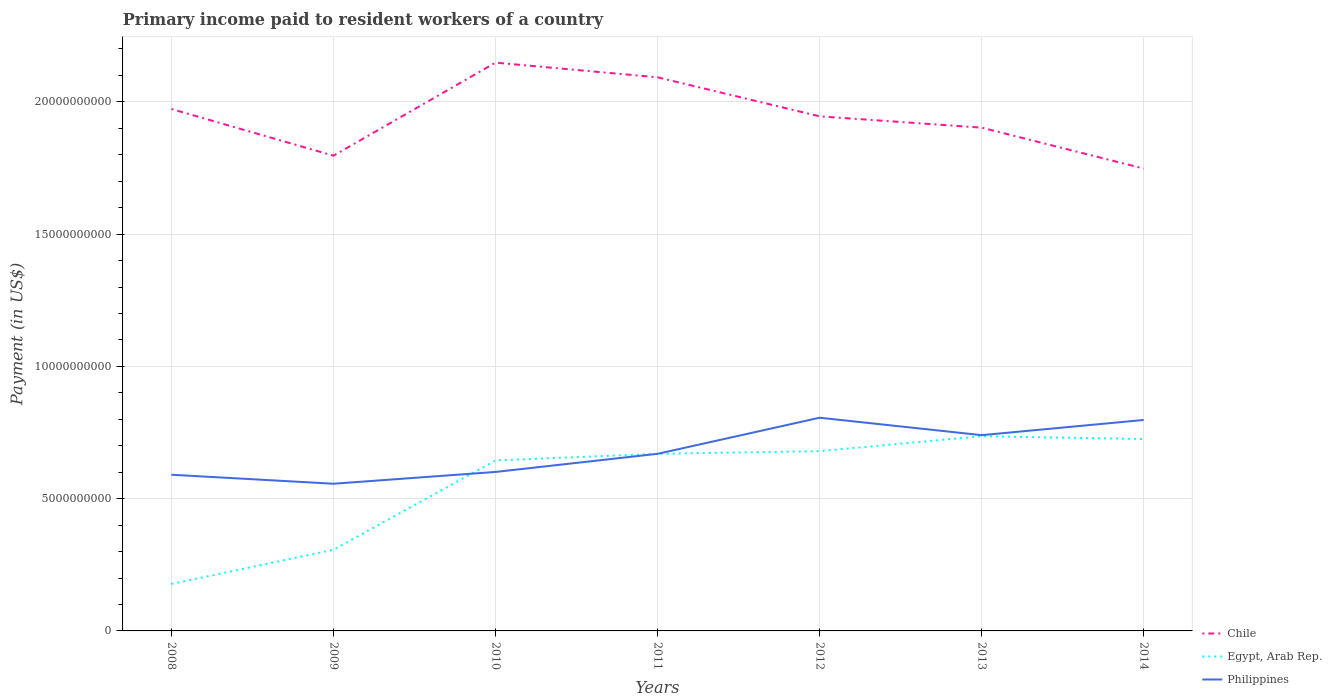Does the line corresponding to Egypt, Arab Rep. intersect with the line corresponding to Chile?
Provide a short and direct response. No. Is the number of lines equal to the number of legend labels?
Ensure brevity in your answer.  Yes. Across all years, what is the maximum amount paid to workers in Egypt, Arab Rep.?
Keep it short and to the point. 1.78e+09. In which year was the amount paid to workers in Philippines maximum?
Keep it short and to the point. 2009. What is the total amount paid to workers in Chile in the graph?
Offer a very short reply. -2.96e+09. What is the difference between the highest and the second highest amount paid to workers in Chile?
Make the answer very short. 4.00e+09. What is the difference between the highest and the lowest amount paid to workers in Chile?
Provide a short and direct response. 4. What is the difference between two consecutive major ticks on the Y-axis?
Offer a very short reply. 5.00e+09. Are the values on the major ticks of Y-axis written in scientific E-notation?
Offer a very short reply. No. Does the graph contain any zero values?
Keep it short and to the point. No. Does the graph contain grids?
Make the answer very short. Yes. Where does the legend appear in the graph?
Your answer should be very brief. Bottom right. How many legend labels are there?
Keep it short and to the point. 3. How are the legend labels stacked?
Your answer should be compact. Vertical. What is the title of the graph?
Keep it short and to the point. Primary income paid to resident workers of a country. What is the label or title of the Y-axis?
Your answer should be compact. Payment (in US$). What is the Payment (in US$) of Chile in 2008?
Give a very brief answer. 1.97e+1. What is the Payment (in US$) in Egypt, Arab Rep. in 2008?
Provide a succinct answer. 1.78e+09. What is the Payment (in US$) of Philippines in 2008?
Your answer should be compact. 5.90e+09. What is the Payment (in US$) of Chile in 2009?
Your answer should be very brief. 1.80e+1. What is the Payment (in US$) of Egypt, Arab Rep. in 2009?
Offer a very short reply. 3.07e+09. What is the Payment (in US$) of Philippines in 2009?
Your answer should be compact. 5.56e+09. What is the Payment (in US$) in Chile in 2010?
Make the answer very short. 2.15e+1. What is the Payment (in US$) in Egypt, Arab Rep. in 2010?
Provide a short and direct response. 6.45e+09. What is the Payment (in US$) of Philippines in 2010?
Keep it short and to the point. 6.01e+09. What is the Payment (in US$) of Chile in 2011?
Your response must be concise. 2.09e+1. What is the Payment (in US$) in Egypt, Arab Rep. in 2011?
Offer a very short reply. 6.69e+09. What is the Payment (in US$) of Philippines in 2011?
Make the answer very short. 6.70e+09. What is the Payment (in US$) of Chile in 2012?
Your response must be concise. 1.95e+1. What is the Payment (in US$) in Egypt, Arab Rep. in 2012?
Your response must be concise. 6.80e+09. What is the Payment (in US$) of Philippines in 2012?
Your response must be concise. 8.06e+09. What is the Payment (in US$) of Chile in 2013?
Ensure brevity in your answer.  1.90e+1. What is the Payment (in US$) of Egypt, Arab Rep. in 2013?
Your answer should be very brief. 7.36e+09. What is the Payment (in US$) in Philippines in 2013?
Your answer should be very brief. 7.40e+09. What is the Payment (in US$) of Chile in 2014?
Your response must be concise. 1.75e+1. What is the Payment (in US$) in Egypt, Arab Rep. in 2014?
Your response must be concise. 7.25e+09. What is the Payment (in US$) in Philippines in 2014?
Your answer should be compact. 7.97e+09. Across all years, what is the maximum Payment (in US$) in Chile?
Offer a very short reply. 2.15e+1. Across all years, what is the maximum Payment (in US$) in Egypt, Arab Rep.?
Your answer should be very brief. 7.36e+09. Across all years, what is the maximum Payment (in US$) in Philippines?
Your response must be concise. 8.06e+09. Across all years, what is the minimum Payment (in US$) of Chile?
Offer a very short reply. 1.75e+1. Across all years, what is the minimum Payment (in US$) of Egypt, Arab Rep.?
Your answer should be very brief. 1.78e+09. Across all years, what is the minimum Payment (in US$) in Philippines?
Your response must be concise. 5.56e+09. What is the total Payment (in US$) in Chile in the graph?
Ensure brevity in your answer.  1.36e+11. What is the total Payment (in US$) in Egypt, Arab Rep. in the graph?
Your answer should be very brief. 3.94e+1. What is the total Payment (in US$) in Philippines in the graph?
Offer a terse response. 4.76e+1. What is the difference between the Payment (in US$) in Chile in 2008 and that in 2009?
Give a very brief answer. 1.76e+09. What is the difference between the Payment (in US$) of Egypt, Arab Rep. in 2008 and that in 2009?
Offer a terse response. -1.29e+09. What is the difference between the Payment (in US$) in Philippines in 2008 and that in 2009?
Give a very brief answer. 3.40e+08. What is the difference between the Payment (in US$) of Chile in 2008 and that in 2010?
Your response must be concise. -1.75e+09. What is the difference between the Payment (in US$) in Egypt, Arab Rep. in 2008 and that in 2010?
Ensure brevity in your answer.  -4.67e+09. What is the difference between the Payment (in US$) of Philippines in 2008 and that in 2010?
Offer a terse response. -1.06e+08. What is the difference between the Payment (in US$) of Chile in 2008 and that in 2011?
Your answer should be compact. -1.20e+09. What is the difference between the Payment (in US$) in Egypt, Arab Rep. in 2008 and that in 2011?
Keep it short and to the point. -4.92e+09. What is the difference between the Payment (in US$) of Philippines in 2008 and that in 2011?
Offer a very short reply. -7.91e+08. What is the difference between the Payment (in US$) of Chile in 2008 and that in 2012?
Provide a succinct answer. 2.77e+08. What is the difference between the Payment (in US$) of Egypt, Arab Rep. in 2008 and that in 2012?
Provide a succinct answer. -5.02e+09. What is the difference between the Payment (in US$) of Philippines in 2008 and that in 2012?
Your answer should be very brief. -2.16e+09. What is the difference between the Payment (in US$) of Chile in 2008 and that in 2013?
Offer a very short reply. 7.05e+08. What is the difference between the Payment (in US$) in Egypt, Arab Rep. in 2008 and that in 2013?
Offer a terse response. -5.58e+09. What is the difference between the Payment (in US$) in Philippines in 2008 and that in 2013?
Ensure brevity in your answer.  -1.50e+09. What is the difference between the Payment (in US$) of Chile in 2008 and that in 2014?
Keep it short and to the point. 2.25e+09. What is the difference between the Payment (in US$) of Egypt, Arab Rep. in 2008 and that in 2014?
Your response must be concise. -5.48e+09. What is the difference between the Payment (in US$) in Philippines in 2008 and that in 2014?
Ensure brevity in your answer.  -2.07e+09. What is the difference between the Payment (in US$) in Chile in 2009 and that in 2010?
Provide a short and direct response. -3.52e+09. What is the difference between the Payment (in US$) in Egypt, Arab Rep. in 2009 and that in 2010?
Keep it short and to the point. -3.38e+09. What is the difference between the Payment (in US$) in Philippines in 2009 and that in 2010?
Your answer should be very brief. -4.46e+08. What is the difference between the Payment (in US$) of Chile in 2009 and that in 2011?
Give a very brief answer. -2.96e+09. What is the difference between the Payment (in US$) in Egypt, Arab Rep. in 2009 and that in 2011?
Make the answer very short. -3.63e+09. What is the difference between the Payment (in US$) in Philippines in 2009 and that in 2011?
Provide a short and direct response. -1.13e+09. What is the difference between the Payment (in US$) in Chile in 2009 and that in 2012?
Provide a short and direct response. -1.49e+09. What is the difference between the Payment (in US$) in Egypt, Arab Rep. in 2009 and that in 2012?
Offer a very short reply. -3.73e+09. What is the difference between the Payment (in US$) of Philippines in 2009 and that in 2012?
Offer a very short reply. -2.50e+09. What is the difference between the Payment (in US$) of Chile in 2009 and that in 2013?
Make the answer very short. -1.06e+09. What is the difference between the Payment (in US$) of Egypt, Arab Rep. in 2009 and that in 2013?
Give a very brief answer. -4.29e+09. What is the difference between the Payment (in US$) in Philippines in 2009 and that in 2013?
Keep it short and to the point. -1.84e+09. What is the difference between the Payment (in US$) of Chile in 2009 and that in 2014?
Give a very brief answer. 4.86e+08. What is the difference between the Payment (in US$) of Egypt, Arab Rep. in 2009 and that in 2014?
Your answer should be very brief. -4.19e+09. What is the difference between the Payment (in US$) of Philippines in 2009 and that in 2014?
Offer a very short reply. -2.41e+09. What is the difference between the Payment (in US$) in Chile in 2010 and that in 2011?
Give a very brief answer. 5.54e+08. What is the difference between the Payment (in US$) in Egypt, Arab Rep. in 2010 and that in 2011?
Your response must be concise. -2.49e+08. What is the difference between the Payment (in US$) in Philippines in 2010 and that in 2011?
Your response must be concise. -6.85e+08. What is the difference between the Payment (in US$) of Chile in 2010 and that in 2012?
Offer a very short reply. 2.03e+09. What is the difference between the Payment (in US$) in Egypt, Arab Rep. in 2010 and that in 2012?
Offer a very short reply. -3.51e+08. What is the difference between the Payment (in US$) in Philippines in 2010 and that in 2012?
Keep it short and to the point. -2.05e+09. What is the difference between the Payment (in US$) in Chile in 2010 and that in 2013?
Your answer should be very brief. 2.46e+09. What is the difference between the Payment (in US$) in Egypt, Arab Rep. in 2010 and that in 2013?
Provide a short and direct response. -9.14e+08. What is the difference between the Payment (in US$) in Philippines in 2010 and that in 2013?
Ensure brevity in your answer.  -1.39e+09. What is the difference between the Payment (in US$) of Chile in 2010 and that in 2014?
Give a very brief answer. 4.00e+09. What is the difference between the Payment (in US$) of Egypt, Arab Rep. in 2010 and that in 2014?
Your answer should be very brief. -8.09e+08. What is the difference between the Payment (in US$) in Philippines in 2010 and that in 2014?
Make the answer very short. -1.96e+09. What is the difference between the Payment (in US$) of Chile in 2011 and that in 2012?
Provide a short and direct response. 1.48e+09. What is the difference between the Payment (in US$) of Egypt, Arab Rep. in 2011 and that in 2012?
Your answer should be very brief. -1.01e+08. What is the difference between the Payment (in US$) of Philippines in 2011 and that in 2012?
Your response must be concise. -1.36e+09. What is the difference between the Payment (in US$) in Chile in 2011 and that in 2013?
Keep it short and to the point. 1.90e+09. What is the difference between the Payment (in US$) in Egypt, Arab Rep. in 2011 and that in 2013?
Provide a succinct answer. -6.65e+08. What is the difference between the Payment (in US$) in Philippines in 2011 and that in 2013?
Provide a short and direct response. -7.06e+08. What is the difference between the Payment (in US$) of Chile in 2011 and that in 2014?
Provide a succinct answer. 3.45e+09. What is the difference between the Payment (in US$) of Egypt, Arab Rep. in 2011 and that in 2014?
Keep it short and to the point. -5.60e+08. What is the difference between the Payment (in US$) of Philippines in 2011 and that in 2014?
Your response must be concise. -1.28e+09. What is the difference between the Payment (in US$) of Chile in 2012 and that in 2013?
Your response must be concise. 4.28e+08. What is the difference between the Payment (in US$) of Egypt, Arab Rep. in 2012 and that in 2013?
Offer a very short reply. -5.64e+08. What is the difference between the Payment (in US$) in Philippines in 2012 and that in 2013?
Offer a terse response. 6.59e+08. What is the difference between the Payment (in US$) of Chile in 2012 and that in 2014?
Offer a very short reply. 1.97e+09. What is the difference between the Payment (in US$) of Egypt, Arab Rep. in 2012 and that in 2014?
Give a very brief answer. -4.58e+08. What is the difference between the Payment (in US$) in Philippines in 2012 and that in 2014?
Offer a very short reply. 8.53e+07. What is the difference between the Payment (in US$) of Chile in 2013 and that in 2014?
Provide a succinct answer. 1.55e+09. What is the difference between the Payment (in US$) of Egypt, Arab Rep. in 2013 and that in 2014?
Ensure brevity in your answer.  1.06e+08. What is the difference between the Payment (in US$) in Philippines in 2013 and that in 2014?
Give a very brief answer. -5.74e+08. What is the difference between the Payment (in US$) in Chile in 2008 and the Payment (in US$) in Egypt, Arab Rep. in 2009?
Give a very brief answer. 1.67e+1. What is the difference between the Payment (in US$) in Chile in 2008 and the Payment (in US$) in Philippines in 2009?
Provide a short and direct response. 1.42e+1. What is the difference between the Payment (in US$) of Egypt, Arab Rep. in 2008 and the Payment (in US$) of Philippines in 2009?
Your response must be concise. -3.79e+09. What is the difference between the Payment (in US$) of Chile in 2008 and the Payment (in US$) of Egypt, Arab Rep. in 2010?
Provide a succinct answer. 1.33e+1. What is the difference between the Payment (in US$) of Chile in 2008 and the Payment (in US$) of Philippines in 2010?
Give a very brief answer. 1.37e+1. What is the difference between the Payment (in US$) of Egypt, Arab Rep. in 2008 and the Payment (in US$) of Philippines in 2010?
Provide a short and direct response. -4.23e+09. What is the difference between the Payment (in US$) in Chile in 2008 and the Payment (in US$) in Egypt, Arab Rep. in 2011?
Make the answer very short. 1.30e+1. What is the difference between the Payment (in US$) in Chile in 2008 and the Payment (in US$) in Philippines in 2011?
Your response must be concise. 1.30e+1. What is the difference between the Payment (in US$) in Egypt, Arab Rep. in 2008 and the Payment (in US$) in Philippines in 2011?
Give a very brief answer. -4.92e+09. What is the difference between the Payment (in US$) in Chile in 2008 and the Payment (in US$) in Egypt, Arab Rep. in 2012?
Offer a terse response. 1.29e+1. What is the difference between the Payment (in US$) in Chile in 2008 and the Payment (in US$) in Philippines in 2012?
Your answer should be compact. 1.17e+1. What is the difference between the Payment (in US$) in Egypt, Arab Rep. in 2008 and the Payment (in US$) in Philippines in 2012?
Offer a very short reply. -6.28e+09. What is the difference between the Payment (in US$) of Chile in 2008 and the Payment (in US$) of Egypt, Arab Rep. in 2013?
Give a very brief answer. 1.24e+1. What is the difference between the Payment (in US$) of Chile in 2008 and the Payment (in US$) of Philippines in 2013?
Provide a short and direct response. 1.23e+1. What is the difference between the Payment (in US$) of Egypt, Arab Rep. in 2008 and the Payment (in US$) of Philippines in 2013?
Provide a succinct answer. -5.62e+09. What is the difference between the Payment (in US$) of Chile in 2008 and the Payment (in US$) of Egypt, Arab Rep. in 2014?
Your answer should be very brief. 1.25e+1. What is the difference between the Payment (in US$) in Chile in 2008 and the Payment (in US$) in Philippines in 2014?
Your answer should be very brief. 1.18e+1. What is the difference between the Payment (in US$) of Egypt, Arab Rep. in 2008 and the Payment (in US$) of Philippines in 2014?
Provide a short and direct response. -6.20e+09. What is the difference between the Payment (in US$) of Chile in 2009 and the Payment (in US$) of Egypt, Arab Rep. in 2010?
Keep it short and to the point. 1.15e+1. What is the difference between the Payment (in US$) of Chile in 2009 and the Payment (in US$) of Philippines in 2010?
Provide a short and direct response. 1.20e+1. What is the difference between the Payment (in US$) of Egypt, Arab Rep. in 2009 and the Payment (in US$) of Philippines in 2010?
Your answer should be compact. -2.94e+09. What is the difference between the Payment (in US$) of Chile in 2009 and the Payment (in US$) of Egypt, Arab Rep. in 2011?
Keep it short and to the point. 1.13e+1. What is the difference between the Payment (in US$) of Chile in 2009 and the Payment (in US$) of Philippines in 2011?
Ensure brevity in your answer.  1.13e+1. What is the difference between the Payment (in US$) in Egypt, Arab Rep. in 2009 and the Payment (in US$) in Philippines in 2011?
Your answer should be very brief. -3.63e+09. What is the difference between the Payment (in US$) of Chile in 2009 and the Payment (in US$) of Egypt, Arab Rep. in 2012?
Provide a short and direct response. 1.12e+1. What is the difference between the Payment (in US$) of Chile in 2009 and the Payment (in US$) of Philippines in 2012?
Make the answer very short. 9.91e+09. What is the difference between the Payment (in US$) in Egypt, Arab Rep. in 2009 and the Payment (in US$) in Philippines in 2012?
Offer a very short reply. -4.99e+09. What is the difference between the Payment (in US$) of Chile in 2009 and the Payment (in US$) of Egypt, Arab Rep. in 2013?
Provide a short and direct response. 1.06e+1. What is the difference between the Payment (in US$) of Chile in 2009 and the Payment (in US$) of Philippines in 2013?
Provide a short and direct response. 1.06e+1. What is the difference between the Payment (in US$) of Egypt, Arab Rep. in 2009 and the Payment (in US$) of Philippines in 2013?
Provide a short and direct response. -4.33e+09. What is the difference between the Payment (in US$) in Chile in 2009 and the Payment (in US$) in Egypt, Arab Rep. in 2014?
Provide a succinct answer. 1.07e+1. What is the difference between the Payment (in US$) of Chile in 2009 and the Payment (in US$) of Philippines in 2014?
Offer a terse response. 9.99e+09. What is the difference between the Payment (in US$) of Egypt, Arab Rep. in 2009 and the Payment (in US$) of Philippines in 2014?
Offer a very short reply. -4.91e+09. What is the difference between the Payment (in US$) in Chile in 2010 and the Payment (in US$) in Egypt, Arab Rep. in 2011?
Keep it short and to the point. 1.48e+1. What is the difference between the Payment (in US$) of Chile in 2010 and the Payment (in US$) of Philippines in 2011?
Make the answer very short. 1.48e+1. What is the difference between the Payment (in US$) in Egypt, Arab Rep. in 2010 and the Payment (in US$) in Philippines in 2011?
Provide a succinct answer. -2.50e+08. What is the difference between the Payment (in US$) in Chile in 2010 and the Payment (in US$) in Egypt, Arab Rep. in 2012?
Provide a succinct answer. 1.47e+1. What is the difference between the Payment (in US$) of Chile in 2010 and the Payment (in US$) of Philippines in 2012?
Ensure brevity in your answer.  1.34e+1. What is the difference between the Payment (in US$) in Egypt, Arab Rep. in 2010 and the Payment (in US$) in Philippines in 2012?
Give a very brief answer. -1.61e+09. What is the difference between the Payment (in US$) of Chile in 2010 and the Payment (in US$) of Egypt, Arab Rep. in 2013?
Provide a short and direct response. 1.41e+1. What is the difference between the Payment (in US$) of Chile in 2010 and the Payment (in US$) of Philippines in 2013?
Ensure brevity in your answer.  1.41e+1. What is the difference between the Payment (in US$) of Egypt, Arab Rep. in 2010 and the Payment (in US$) of Philippines in 2013?
Offer a very short reply. -9.55e+08. What is the difference between the Payment (in US$) of Chile in 2010 and the Payment (in US$) of Egypt, Arab Rep. in 2014?
Your answer should be very brief. 1.42e+1. What is the difference between the Payment (in US$) in Chile in 2010 and the Payment (in US$) in Philippines in 2014?
Keep it short and to the point. 1.35e+1. What is the difference between the Payment (in US$) of Egypt, Arab Rep. in 2010 and the Payment (in US$) of Philippines in 2014?
Offer a very short reply. -1.53e+09. What is the difference between the Payment (in US$) in Chile in 2011 and the Payment (in US$) in Egypt, Arab Rep. in 2012?
Your response must be concise. 1.41e+1. What is the difference between the Payment (in US$) in Chile in 2011 and the Payment (in US$) in Philippines in 2012?
Make the answer very short. 1.29e+1. What is the difference between the Payment (in US$) in Egypt, Arab Rep. in 2011 and the Payment (in US$) in Philippines in 2012?
Give a very brief answer. -1.37e+09. What is the difference between the Payment (in US$) in Chile in 2011 and the Payment (in US$) in Egypt, Arab Rep. in 2013?
Keep it short and to the point. 1.36e+1. What is the difference between the Payment (in US$) in Chile in 2011 and the Payment (in US$) in Philippines in 2013?
Make the answer very short. 1.35e+1. What is the difference between the Payment (in US$) in Egypt, Arab Rep. in 2011 and the Payment (in US$) in Philippines in 2013?
Provide a short and direct response. -7.06e+08. What is the difference between the Payment (in US$) of Chile in 2011 and the Payment (in US$) of Egypt, Arab Rep. in 2014?
Ensure brevity in your answer.  1.37e+1. What is the difference between the Payment (in US$) of Chile in 2011 and the Payment (in US$) of Philippines in 2014?
Offer a very short reply. 1.30e+1. What is the difference between the Payment (in US$) of Egypt, Arab Rep. in 2011 and the Payment (in US$) of Philippines in 2014?
Give a very brief answer. -1.28e+09. What is the difference between the Payment (in US$) of Chile in 2012 and the Payment (in US$) of Egypt, Arab Rep. in 2013?
Give a very brief answer. 1.21e+1. What is the difference between the Payment (in US$) in Chile in 2012 and the Payment (in US$) in Philippines in 2013?
Offer a terse response. 1.21e+1. What is the difference between the Payment (in US$) in Egypt, Arab Rep. in 2012 and the Payment (in US$) in Philippines in 2013?
Offer a very short reply. -6.05e+08. What is the difference between the Payment (in US$) in Chile in 2012 and the Payment (in US$) in Egypt, Arab Rep. in 2014?
Ensure brevity in your answer.  1.22e+1. What is the difference between the Payment (in US$) in Chile in 2012 and the Payment (in US$) in Philippines in 2014?
Offer a very short reply. 1.15e+1. What is the difference between the Payment (in US$) of Egypt, Arab Rep. in 2012 and the Payment (in US$) of Philippines in 2014?
Offer a very short reply. -1.18e+09. What is the difference between the Payment (in US$) in Chile in 2013 and the Payment (in US$) in Egypt, Arab Rep. in 2014?
Keep it short and to the point. 1.18e+1. What is the difference between the Payment (in US$) in Chile in 2013 and the Payment (in US$) in Philippines in 2014?
Give a very brief answer. 1.11e+1. What is the difference between the Payment (in US$) of Egypt, Arab Rep. in 2013 and the Payment (in US$) of Philippines in 2014?
Provide a short and direct response. -6.15e+08. What is the average Payment (in US$) in Chile per year?
Your response must be concise. 1.94e+1. What is the average Payment (in US$) in Egypt, Arab Rep. per year?
Offer a terse response. 5.63e+09. What is the average Payment (in US$) in Philippines per year?
Make the answer very short. 6.80e+09. In the year 2008, what is the difference between the Payment (in US$) in Chile and Payment (in US$) in Egypt, Arab Rep.?
Offer a terse response. 1.80e+1. In the year 2008, what is the difference between the Payment (in US$) of Chile and Payment (in US$) of Philippines?
Offer a very short reply. 1.38e+1. In the year 2008, what is the difference between the Payment (in US$) of Egypt, Arab Rep. and Payment (in US$) of Philippines?
Ensure brevity in your answer.  -4.13e+09. In the year 2009, what is the difference between the Payment (in US$) in Chile and Payment (in US$) in Egypt, Arab Rep.?
Your answer should be compact. 1.49e+1. In the year 2009, what is the difference between the Payment (in US$) of Chile and Payment (in US$) of Philippines?
Provide a short and direct response. 1.24e+1. In the year 2009, what is the difference between the Payment (in US$) of Egypt, Arab Rep. and Payment (in US$) of Philippines?
Offer a very short reply. -2.50e+09. In the year 2010, what is the difference between the Payment (in US$) in Chile and Payment (in US$) in Egypt, Arab Rep.?
Your answer should be compact. 1.50e+1. In the year 2010, what is the difference between the Payment (in US$) in Chile and Payment (in US$) in Philippines?
Offer a very short reply. 1.55e+1. In the year 2010, what is the difference between the Payment (in US$) in Egypt, Arab Rep. and Payment (in US$) in Philippines?
Keep it short and to the point. 4.35e+08. In the year 2011, what is the difference between the Payment (in US$) in Chile and Payment (in US$) in Egypt, Arab Rep.?
Your answer should be very brief. 1.42e+1. In the year 2011, what is the difference between the Payment (in US$) in Chile and Payment (in US$) in Philippines?
Make the answer very short. 1.42e+1. In the year 2011, what is the difference between the Payment (in US$) of Egypt, Arab Rep. and Payment (in US$) of Philippines?
Ensure brevity in your answer.  -5.25e+05. In the year 2012, what is the difference between the Payment (in US$) of Chile and Payment (in US$) of Egypt, Arab Rep.?
Keep it short and to the point. 1.27e+1. In the year 2012, what is the difference between the Payment (in US$) in Chile and Payment (in US$) in Philippines?
Make the answer very short. 1.14e+1. In the year 2012, what is the difference between the Payment (in US$) in Egypt, Arab Rep. and Payment (in US$) in Philippines?
Provide a short and direct response. -1.26e+09. In the year 2013, what is the difference between the Payment (in US$) of Chile and Payment (in US$) of Egypt, Arab Rep.?
Your answer should be compact. 1.17e+1. In the year 2013, what is the difference between the Payment (in US$) in Chile and Payment (in US$) in Philippines?
Offer a terse response. 1.16e+1. In the year 2013, what is the difference between the Payment (in US$) of Egypt, Arab Rep. and Payment (in US$) of Philippines?
Your answer should be very brief. -4.11e+07. In the year 2014, what is the difference between the Payment (in US$) of Chile and Payment (in US$) of Egypt, Arab Rep.?
Your answer should be compact. 1.02e+1. In the year 2014, what is the difference between the Payment (in US$) in Chile and Payment (in US$) in Philippines?
Make the answer very short. 9.51e+09. In the year 2014, what is the difference between the Payment (in US$) in Egypt, Arab Rep. and Payment (in US$) in Philippines?
Offer a very short reply. -7.20e+08. What is the ratio of the Payment (in US$) in Chile in 2008 to that in 2009?
Ensure brevity in your answer.  1.1. What is the ratio of the Payment (in US$) in Egypt, Arab Rep. in 2008 to that in 2009?
Your response must be concise. 0.58. What is the ratio of the Payment (in US$) in Philippines in 2008 to that in 2009?
Provide a succinct answer. 1.06. What is the ratio of the Payment (in US$) of Chile in 2008 to that in 2010?
Ensure brevity in your answer.  0.92. What is the ratio of the Payment (in US$) of Egypt, Arab Rep. in 2008 to that in 2010?
Ensure brevity in your answer.  0.28. What is the ratio of the Payment (in US$) in Philippines in 2008 to that in 2010?
Your answer should be compact. 0.98. What is the ratio of the Payment (in US$) of Chile in 2008 to that in 2011?
Make the answer very short. 0.94. What is the ratio of the Payment (in US$) in Egypt, Arab Rep. in 2008 to that in 2011?
Offer a very short reply. 0.27. What is the ratio of the Payment (in US$) in Philippines in 2008 to that in 2011?
Your response must be concise. 0.88. What is the ratio of the Payment (in US$) of Chile in 2008 to that in 2012?
Provide a short and direct response. 1.01. What is the ratio of the Payment (in US$) of Egypt, Arab Rep. in 2008 to that in 2012?
Keep it short and to the point. 0.26. What is the ratio of the Payment (in US$) of Philippines in 2008 to that in 2012?
Offer a very short reply. 0.73. What is the ratio of the Payment (in US$) of Chile in 2008 to that in 2013?
Offer a very short reply. 1.04. What is the ratio of the Payment (in US$) of Egypt, Arab Rep. in 2008 to that in 2013?
Give a very brief answer. 0.24. What is the ratio of the Payment (in US$) in Philippines in 2008 to that in 2013?
Provide a short and direct response. 0.8. What is the ratio of the Payment (in US$) in Chile in 2008 to that in 2014?
Make the answer very short. 1.13. What is the ratio of the Payment (in US$) of Egypt, Arab Rep. in 2008 to that in 2014?
Offer a very short reply. 0.24. What is the ratio of the Payment (in US$) in Philippines in 2008 to that in 2014?
Offer a very short reply. 0.74. What is the ratio of the Payment (in US$) in Chile in 2009 to that in 2010?
Provide a succinct answer. 0.84. What is the ratio of the Payment (in US$) of Egypt, Arab Rep. in 2009 to that in 2010?
Make the answer very short. 0.48. What is the ratio of the Payment (in US$) in Philippines in 2009 to that in 2010?
Offer a terse response. 0.93. What is the ratio of the Payment (in US$) of Chile in 2009 to that in 2011?
Your answer should be very brief. 0.86. What is the ratio of the Payment (in US$) in Egypt, Arab Rep. in 2009 to that in 2011?
Keep it short and to the point. 0.46. What is the ratio of the Payment (in US$) of Philippines in 2009 to that in 2011?
Your answer should be compact. 0.83. What is the ratio of the Payment (in US$) in Chile in 2009 to that in 2012?
Offer a terse response. 0.92. What is the ratio of the Payment (in US$) of Egypt, Arab Rep. in 2009 to that in 2012?
Offer a terse response. 0.45. What is the ratio of the Payment (in US$) of Philippines in 2009 to that in 2012?
Make the answer very short. 0.69. What is the ratio of the Payment (in US$) of Chile in 2009 to that in 2013?
Provide a short and direct response. 0.94. What is the ratio of the Payment (in US$) of Egypt, Arab Rep. in 2009 to that in 2013?
Your answer should be compact. 0.42. What is the ratio of the Payment (in US$) of Philippines in 2009 to that in 2013?
Offer a very short reply. 0.75. What is the ratio of the Payment (in US$) of Chile in 2009 to that in 2014?
Offer a very short reply. 1.03. What is the ratio of the Payment (in US$) in Egypt, Arab Rep. in 2009 to that in 2014?
Ensure brevity in your answer.  0.42. What is the ratio of the Payment (in US$) in Philippines in 2009 to that in 2014?
Make the answer very short. 0.7. What is the ratio of the Payment (in US$) of Chile in 2010 to that in 2011?
Provide a succinct answer. 1.03. What is the ratio of the Payment (in US$) of Egypt, Arab Rep. in 2010 to that in 2011?
Provide a succinct answer. 0.96. What is the ratio of the Payment (in US$) of Philippines in 2010 to that in 2011?
Offer a terse response. 0.9. What is the ratio of the Payment (in US$) in Chile in 2010 to that in 2012?
Your response must be concise. 1.1. What is the ratio of the Payment (in US$) of Egypt, Arab Rep. in 2010 to that in 2012?
Your answer should be very brief. 0.95. What is the ratio of the Payment (in US$) of Philippines in 2010 to that in 2012?
Your answer should be very brief. 0.75. What is the ratio of the Payment (in US$) of Chile in 2010 to that in 2013?
Give a very brief answer. 1.13. What is the ratio of the Payment (in US$) in Egypt, Arab Rep. in 2010 to that in 2013?
Offer a very short reply. 0.88. What is the ratio of the Payment (in US$) of Philippines in 2010 to that in 2013?
Your response must be concise. 0.81. What is the ratio of the Payment (in US$) in Chile in 2010 to that in 2014?
Offer a very short reply. 1.23. What is the ratio of the Payment (in US$) of Egypt, Arab Rep. in 2010 to that in 2014?
Your answer should be compact. 0.89. What is the ratio of the Payment (in US$) in Philippines in 2010 to that in 2014?
Your answer should be compact. 0.75. What is the ratio of the Payment (in US$) of Chile in 2011 to that in 2012?
Offer a terse response. 1.08. What is the ratio of the Payment (in US$) of Egypt, Arab Rep. in 2011 to that in 2012?
Provide a succinct answer. 0.99. What is the ratio of the Payment (in US$) of Philippines in 2011 to that in 2012?
Provide a succinct answer. 0.83. What is the ratio of the Payment (in US$) of Egypt, Arab Rep. in 2011 to that in 2013?
Your answer should be compact. 0.91. What is the ratio of the Payment (in US$) in Philippines in 2011 to that in 2013?
Give a very brief answer. 0.9. What is the ratio of the Payment (in US$) of Chile in 2011 to that in 2014?
Your response must be concise. 1.2. What is the ratio of the Payment (in US$) in Egypt, Arab Rep. in 2011 to that in 2014?
Your response must be concise. 0.92. What is the ratio of the Payment (in US$) in Philippines in 2011 to that in 2014?
Keep it short and to the point. 0.84. What is the ratio of the Payment (in US$) of Chile in 2012 to that in 2013?
Ensure brevity in your answer.  1.02. What is the ratio of the Payment (in US$) of Egypt, Arab Rep. in 2012 to that in 2013?
Ensure brevity in your answer.  0.92. What is the ratio of the Payment (in US$) in Philippines in 2012 to that in 2013?
Your answer should be compact. 1.09. What is the ratio of the Payment (in US$) of Chile in 2012 to that in 2014?
Ensure brevity in your answer.  1.11. What is the ratio of the Payment (in US$) of Egypt, Arab Rep. in 2012 to that in 2014?
Your answer should be compact. 0.94. What is the ratio of the Payment (in US$) of Philippines in 2012 to that in 2014?
Offer a very short reply. 1.01. What is the ratio of the Payment (in US$) in Chile in 2013 to that in 2014?
Provide a succinct answer. 1.09. What is the ratio of the Payment (in US$) in Egypt, Arab Rep. in 2013 to that in 2014?
Give a very brief answer. 1.01. What is the ratio of the Payment (in US$) in Philippines in 2013 to that in 2014?
Your answer should be very brief. 0.93. What is the difference between the highest and the second highest Payment (in US$) in Chile?
Ensure brevity in your answer.  5.54e+08. What is the difference between the highest and the second highest Payment (in US$) of Egypt, Arab Rep.?
Offer a very short reply. 1.06e+08. What is the difference between the highest and the second highest Payment (in US$) in Philippines?
Ensure brevity in your answer.  8.53e+07. What is the difference between the highest and the lowest Payment (in US$) in Chile?
Provide a succinct answer. 4.00e+09. What is the difference between the highest and the lowest Payment (in US$) in Egypt, Arab Rep.?
Your answer should be very brief. 5.58e+09. What is the difference between the highest and the lowest Payment (in US$) in Philippines?
Your response must be concise. 2.50e+09. 